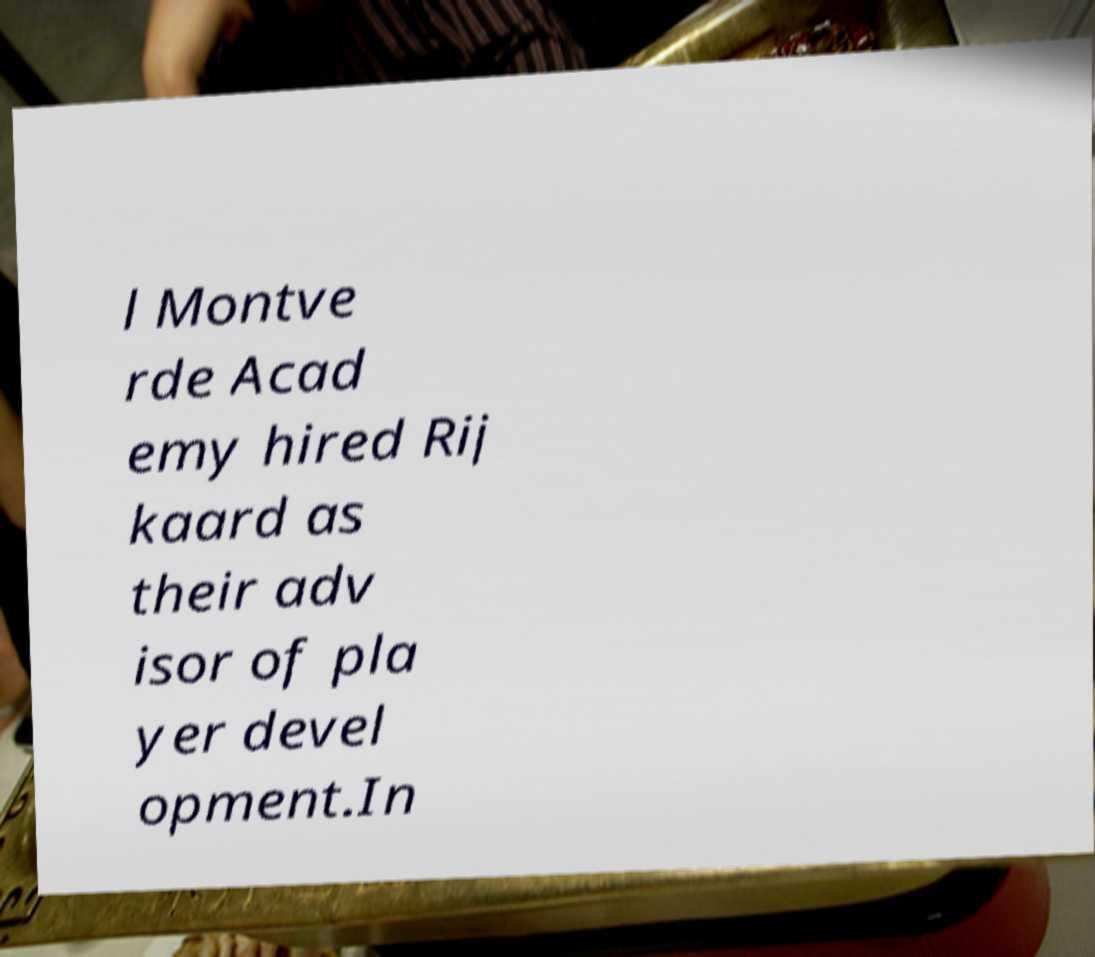Please identify and transcribe the text found in this image. l Montve rde Acad emy hired Rij kaard as their adv isor of pla yer devel opment.In 